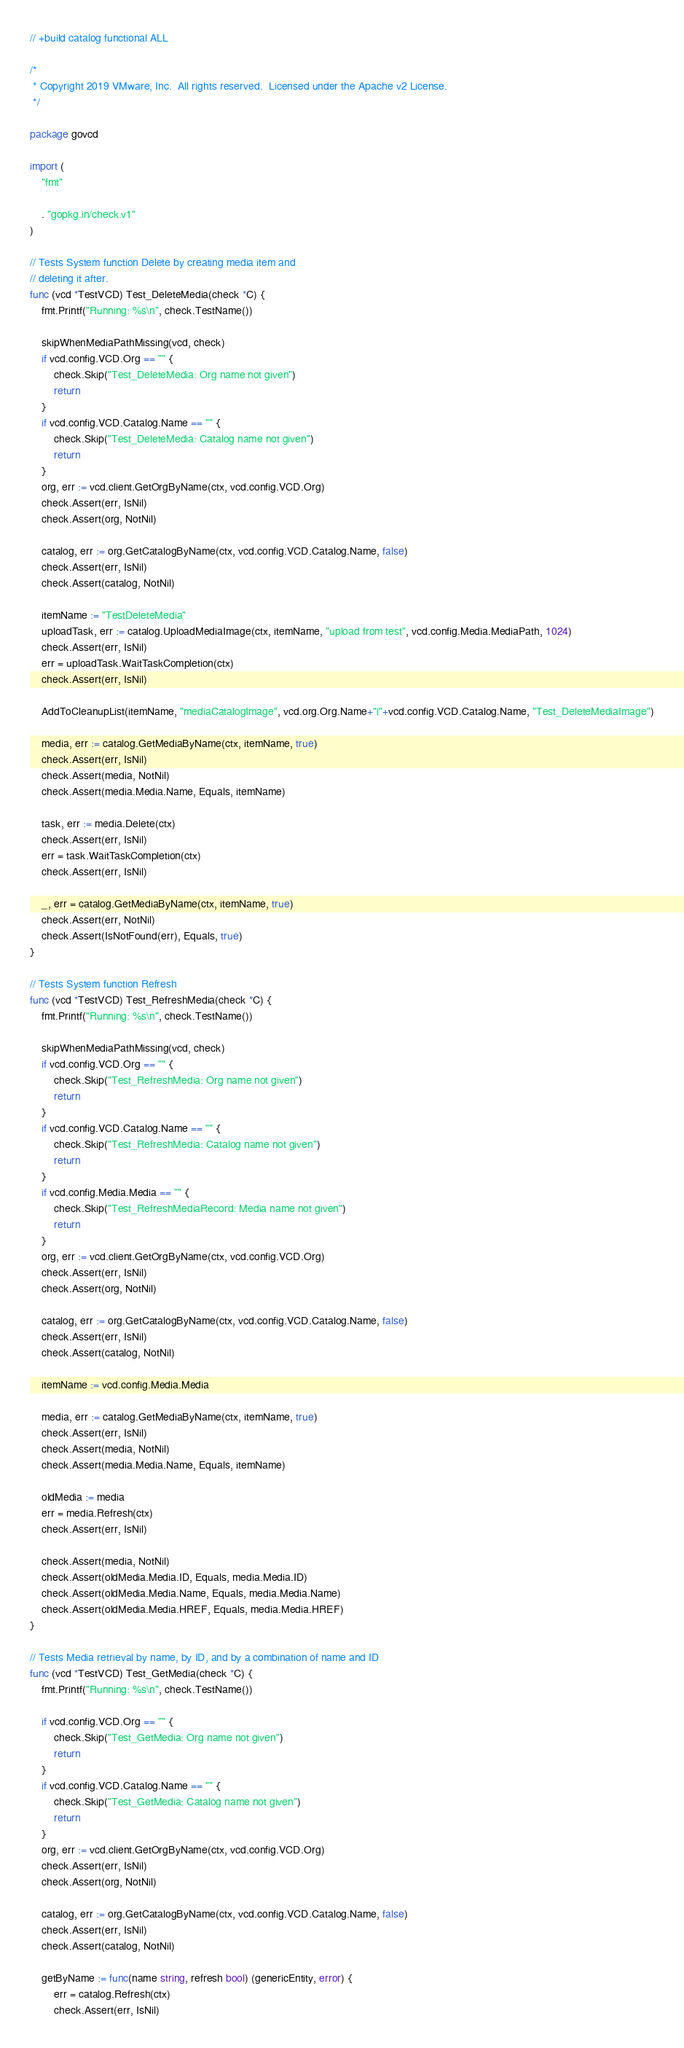Convert code to text. <code><loc_0><loc_0><loc_500><loc_500><_Go_>// +build catalog functional ALL

/*
 * Copyright 2019 VMware, Inc.  All rights reserved.  Licensed under the Apache v2 License.
 */

package govcd

import (
	"fmt"

	. "gopkg.in/check.v1"
)

// Tests System function Delete by creating media item and
// deleting it after.
func (vcd *TestVCD) Test_DeleteMedia(check *C) {
	fmt.Printf("Running: %s\n", check.TestName())

	skipWhenMediaPathMissing(vcd, check)
	if vcd.config.VCD.Org == "" {
		check.Skip("Test_DeleteMedia: Org name not given")
		return
	}
	if vcd.config.VCD.Catalog.Name == "" {
		check.Skip("Test_DeleteMedia: Catalog name not given")
		return
	}
	org, err := vcd.client.GetOrgByName(ctx, vcd.config.VCD.Org)
	check.Assert(err, IsNil)
	check.Assert(org, NotNil)

	catalog, err := org.GetCatalogByName(ctx, vcd.config.VCD.Catalog.Name, false)
	check.Assert(err, IsNil)
	check.Assert(catalog, NotNil)

	itemName := "TestDeleteMedia"
	uploadTask, err := catalog.UploadMediaImage(ctx, itemName, "upload from test", vcd.config.Media.MediaPath, 1024)
	check.Assert(err, IsNil)
	err = uploadTask.WaitTaskCompletion(ctx)
	check.Assert(err, IsNil)

	AddToCleanupList(itemName, "mediaCatalogImage", vcd.org.Org.Name+"|"+vcd.config.VCD.Catalog.Name, "Test_DeleteMediaImage")

	media, err := catalog.GetMediaByName(ctx, itemName, true)
	check.Assert(err, IsNil)
	check.Assert(media, NotNil)
	check.Assert(media.Media.Name, Equals, itemName)

	task, err := media.Delete(ctx)
	check.Assert(err, IsNil)
	err = task.WaitTaskCompletion(ctx)
	check.Assert(err, IsNil)

	_, err = catalog.GetMediaByName(ctx, itemName, true)
	check.Assert(err, NotNil)
	check.Assert(IsNotFound(err), Equals, true)
}

// Tests System function Refresh
func (vcd *TestVCD) Test_RefreshMedia(check *C) {
	fmt.Printf("Running: %s\n", check.TestName())

	skipWhenMediaPathMissing(vcd, check)
	if vcd.config.VCD.Org == "" {
		check.Skip("Test_RefreshMedia: Org name not given")
		return
	}
	if vcd.config.VCD.Catalog.Name == "" {
		check.Skip("Test_RefreshMedia: Catalog name not given")
		return
	}
	if vcd.config.Media.Media == "" {
		check.Skip("Test_RefreshMediaRecord: Media name not given")
		return
	}
	org, err := vcd.client.GetOrgByName(ctx, vcd.config.VCD.Org)
	check.Assert(err, IsNil)
	check.Assert(org, NotNil)

	catalog, err := org.GetCatalogByName(ctx, vcd.config.VCD.Catalog.Name, false)
	check.Assert(err, IsNil)
	check.Assert(catalog, NotNil)

	itemName := vcd.config.Media.Media

	media, err := catalog.GetMediaByName(ctx, itemName, true)
	check.Assert(err, IsNil)
	check.Assert(media, NotNil)
	check.Assert(media.Media.Name, Equals, itemName)

	oldMedia := media
	err = media.Refresh(ctx)
	check.Assert(err, IsNil)

	check.Assert(media, NotNil)
	check.Assert(oldMedia.Media.ID, Equals, media.Media.ID)
	check.Assert(oldMedia.Media.Name, Equals, media.Media.Name)
	check.Assert(oldMedia.Media.HREF, Equals, media.Media.HREF)
}

// Tests Media retrieval by name, by ID, and by a combination of name and ID
func (vcd *TestVCD) Test_GetMedia(check *C) {
	fmt.Printf("Running: %s\n", check.TestName())

	if vcd.config.VCD.Org == "" {
		check.Skip("Test_GetMedia: Org name not given")
		return
	}
	if vcd.config.VCD.Catalog.Name == "" {
		check.Skip("Test_GetMedia: Catalog name not given")
		return
	}
	org, err := vcd.client.GetOrgByName(ctx, vcd.config.VCD.Org)
	check.Assert(err, IsNil)
	check.Assert(org, NotNil)

	catalog, err := org.GetCatalogByName(ctx, vcd.config.VCD.Catalog.Name, false)
	check.Assert(err, IsNil)
	check.Assert(catalog, NotNil)

	getByName := func(name string, refresh bool) (genericEntity, error) {
		err = catalog.Refresh(ctx)
		check.Assert(err, IsNil)</code> 